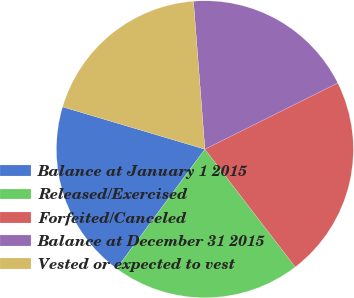Convert chart to OTSL. <chart><loc_0><loc_0><loc_500><loc_500><pie_chart><fcel>Balance at January 1 2015<fcel>Released/Exercised<fcel>Forfeited/Canceled<fcel>Balance at December 31 2015<fcel>Vested or expected to vest<nl><fcel>19.47%<fcel>20.55%<fcel>21.95%<fcel>18.86%<fcel>19.17%<nl></chart> 